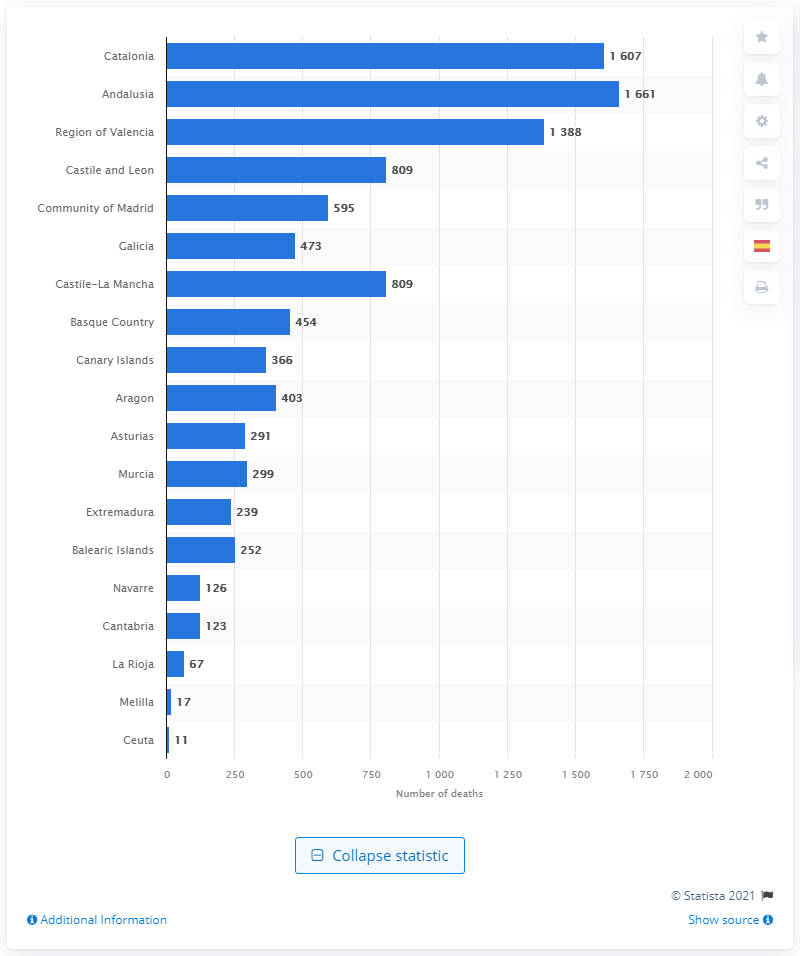Give some essential details in this illustration. The autonomous community of Andalusia had the highest number of diabetes mellitus deaths, according to data. 